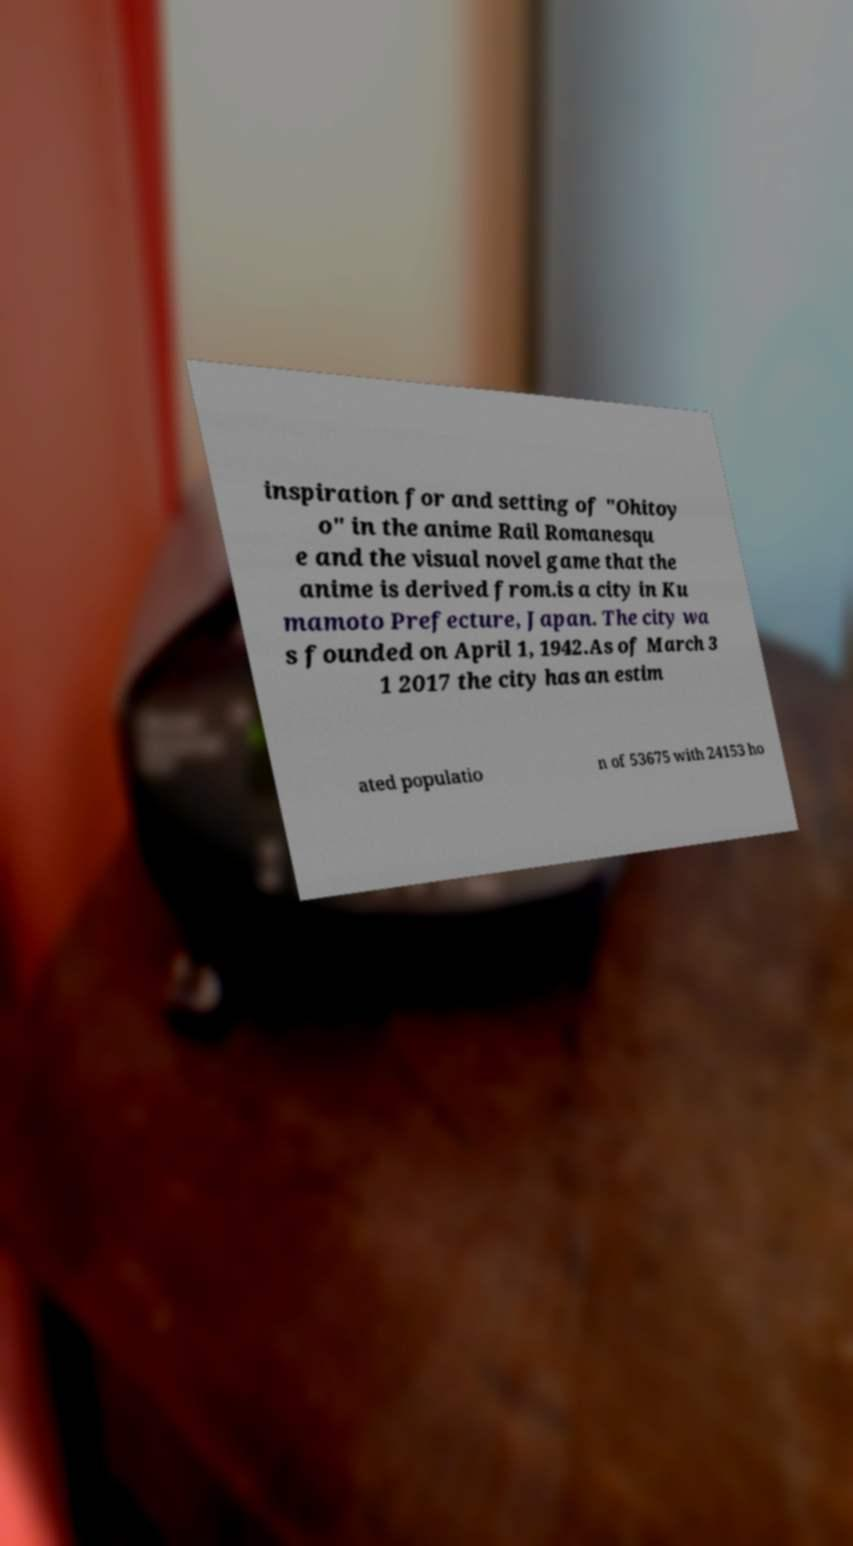What messages or text are displayed in this image? I need them in a readable, typed format. inspiration for and setting of "Ohitoy o" in the anime Rail Romanesqu e and the visual novel game that the anime is derived from.is a city in Ku mamoto Prefecture, Japan. The city wa s founded on April 1, 1942.As of March 3 1 2017 the city has an estim ated populatio n of 53675 with 24153 ho 